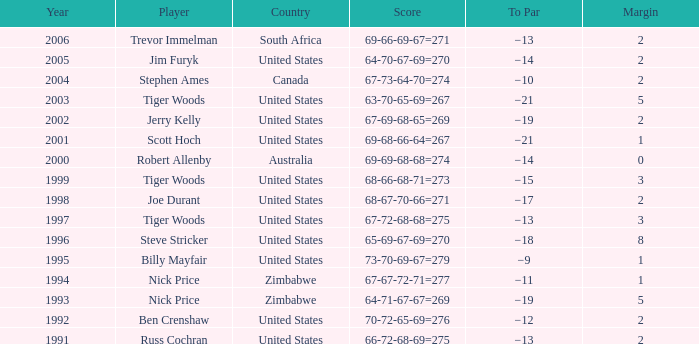How many years have a Player of joe durant, and Earnings ($) larger than 396,000? 0.0. 